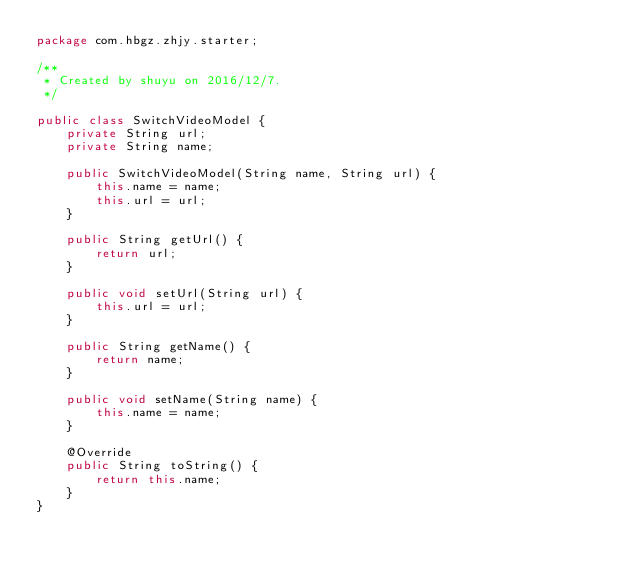<code> <loc_0><loc_0><loc_500><loc_500><_Java_>package com.hbgz.zhjy.starter;

/**
 * Created by shuyu on 2016/12/7.
 */

public class SwitchVideoModel {
    private String url;
    private String name;

    public SwitchVideoModel(String name, String url) {
        this.name = name;
        this.url = url;
    }

    public String getUrl() {
        return url;
    }

    public void setUrl(String url) {
        this.url = url;
    }

    public String getName() {
        return name;
    }

    public void setName(String name) {
        this.name = name;
    }

    @Override
    public String toString() {
        return this.name;
    }
}</code> 